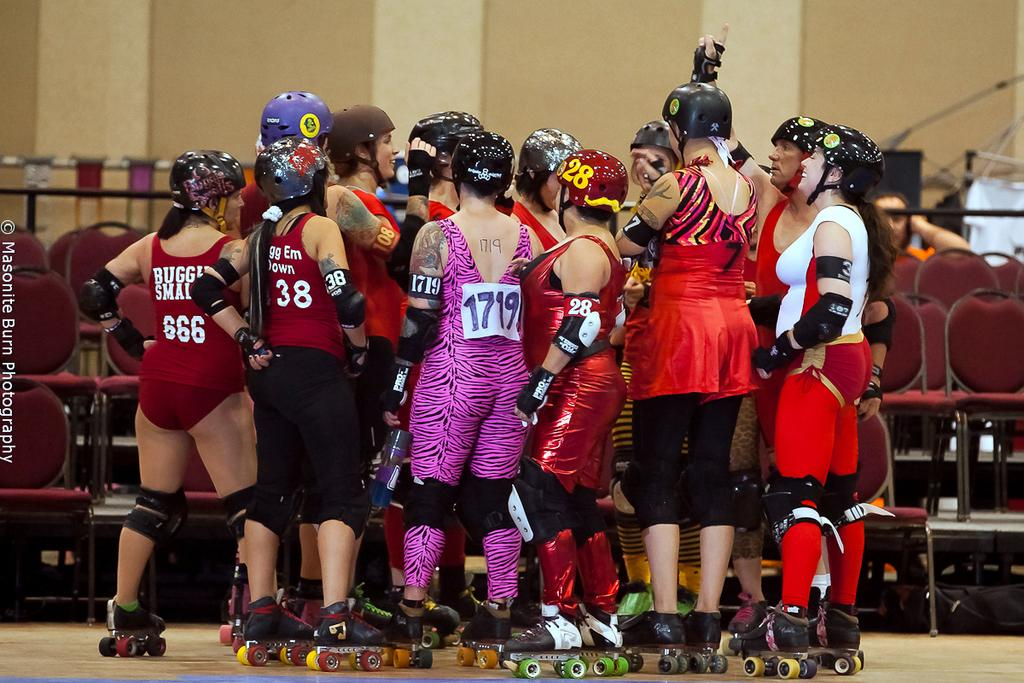Provide a one-sentence caption for the provided image. 1719 wears purple zebra in a group with other roller skaters. 